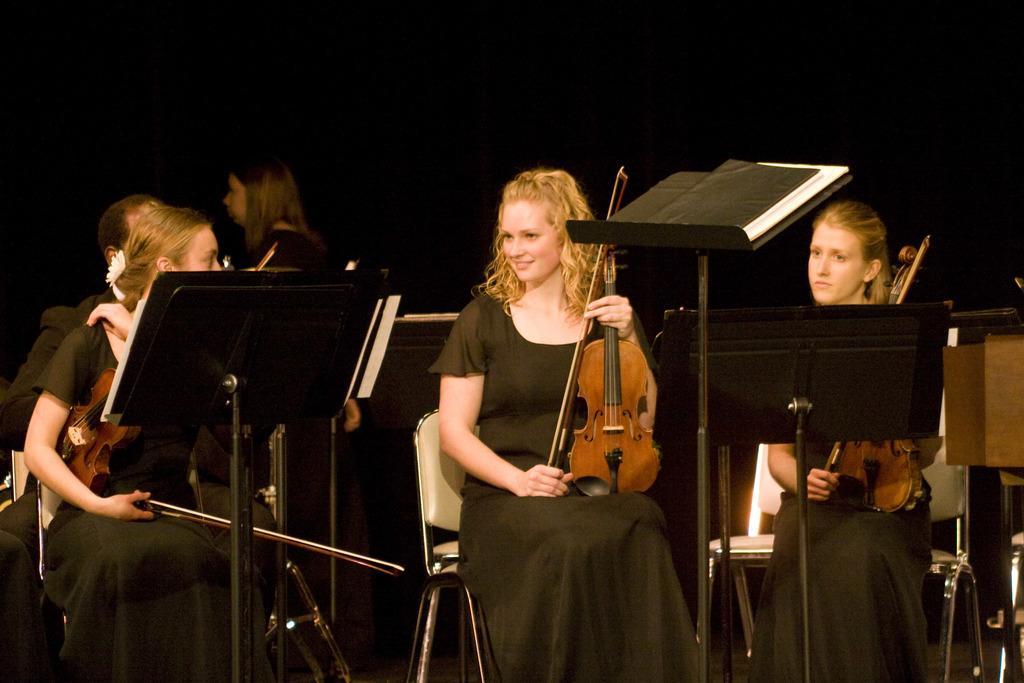In one or two sentences, can you explain what this image depicts? Here we can see three women are sitting on the chairs. And they are holding a guitar with their hands. There are books and this is sand. In the background Here we can see two persons. 